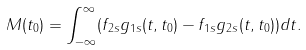<formula> <loc_0><loc_0><loc_500><loc_500>M ( t _ { 0 } ) = \int _ { - \infty } ^ { \infty } ( f _ { 2 s } g _ { 1 s } ( t , t _ { 0 } ) - f _ { 1 s } g _ { 2 s } ( t , t _ { 0 } ) ) d t .</formula> 